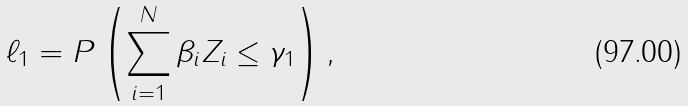<formula> <loc_0><loc_0><loc_500><loc_500>\ell _ { 1 } = P \left ( \sum _ { i = 1 } ^ { N } { \beta _ { i } Z _ { i } } \leq \gamma _ { 1 } \right ) ,</formula> 